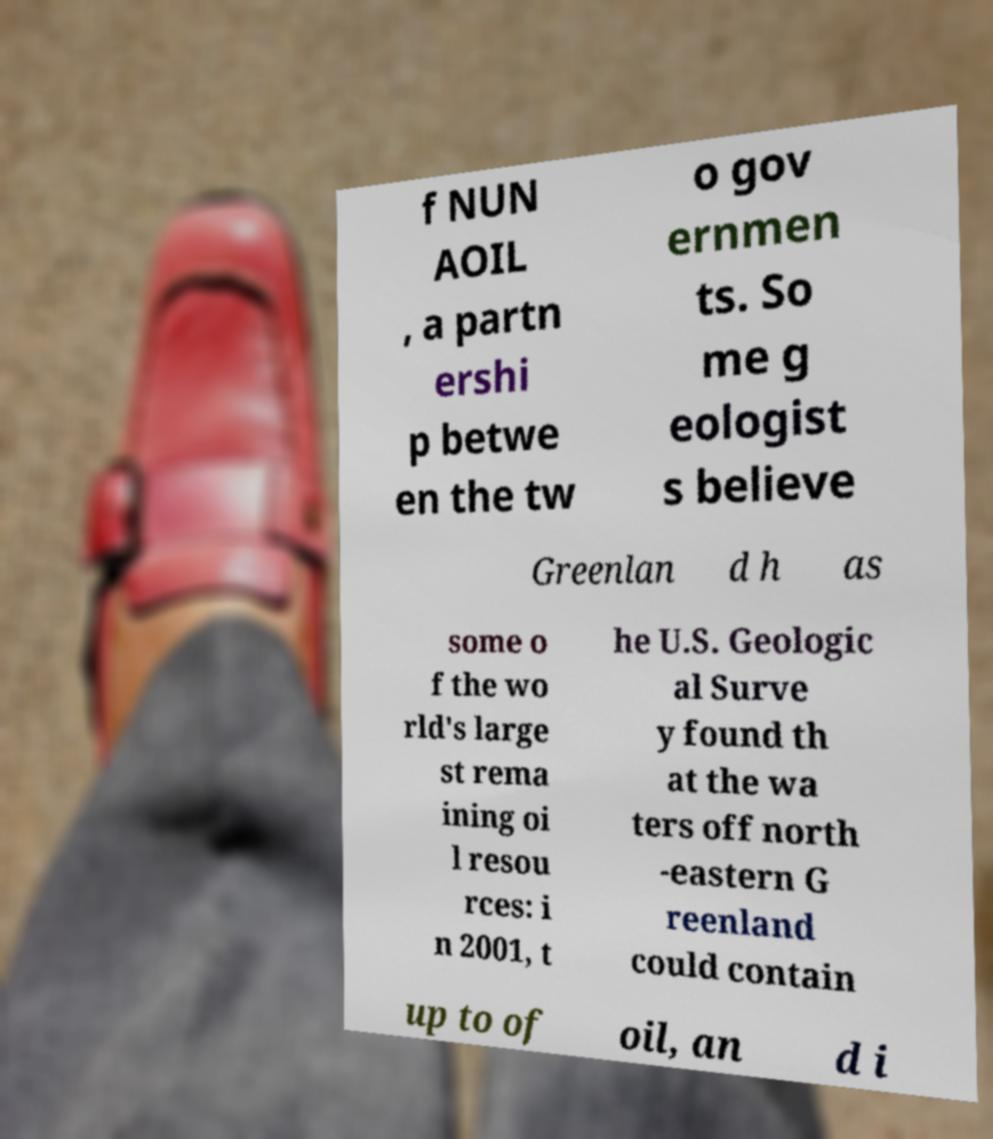Can you accurately transcribe the text from the provided image for me? f NUN AOIL , a partn ershi p betwe en the tw o gov ernmen ts. So me g eologist s believe Greenlan d h as some o f the wo rld's large st rema ining oi l resou rces: i n 2001, t he U.S. Geologic al Surve y found th at the wa ters off north -eastern G reenland could contain up to of oil, an d i 